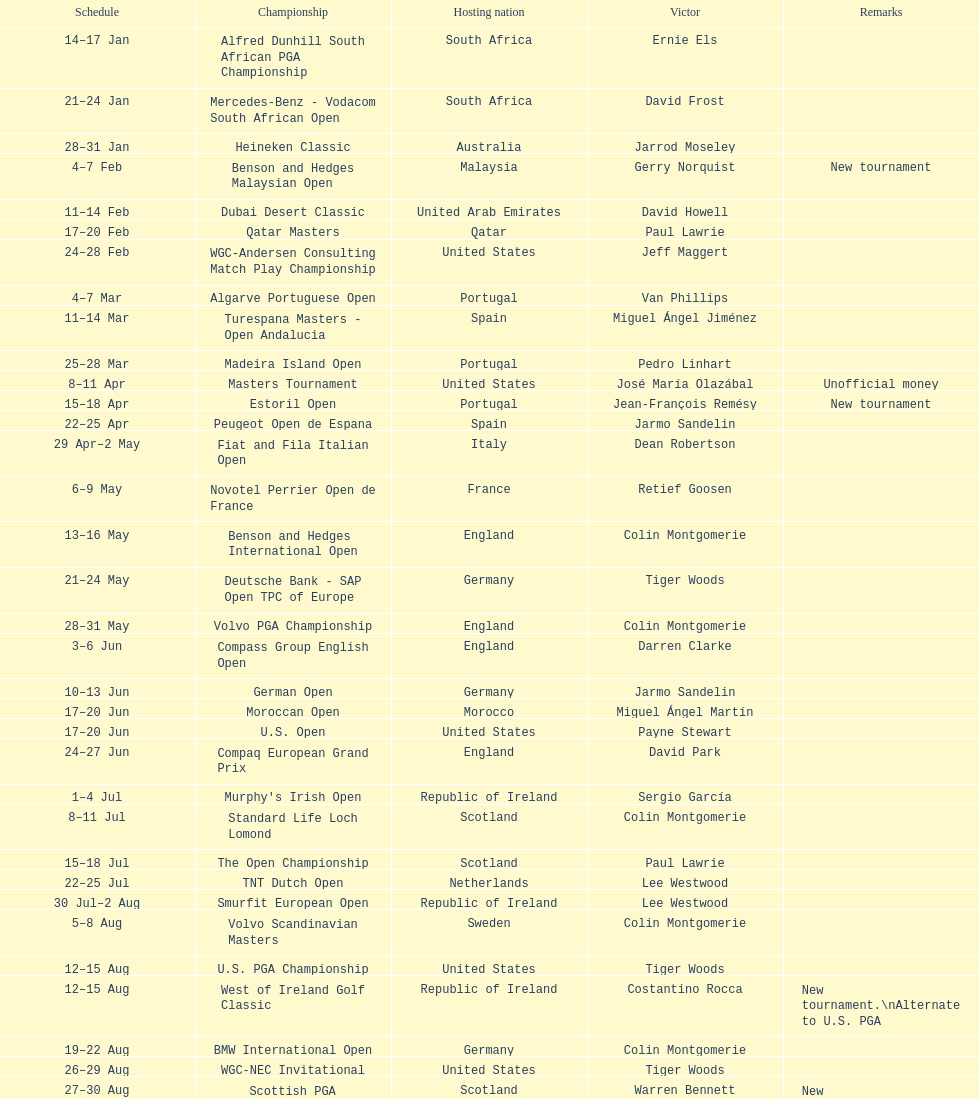How many tournaments began before aug 15th 31. 